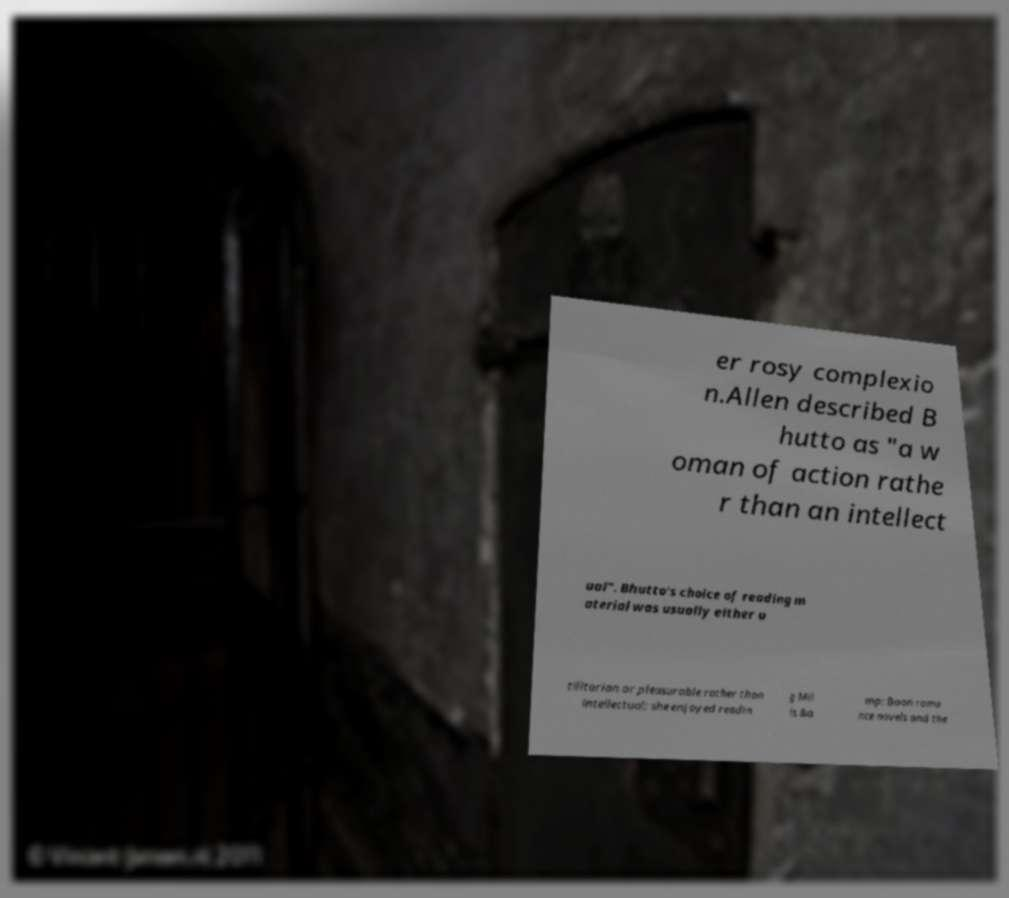Can you accurately transcribe the text from the provided image for me? er rosy complexio n.Allen described B hutto as "a w oman of action rathe r than an intellect ual". Bhutto's choice of reading m aterial was usually either u tilitarian or pleasurable rather than intellectual; she enjoyed readin g Mil ls &a mp; Boon roma nce novels and the 